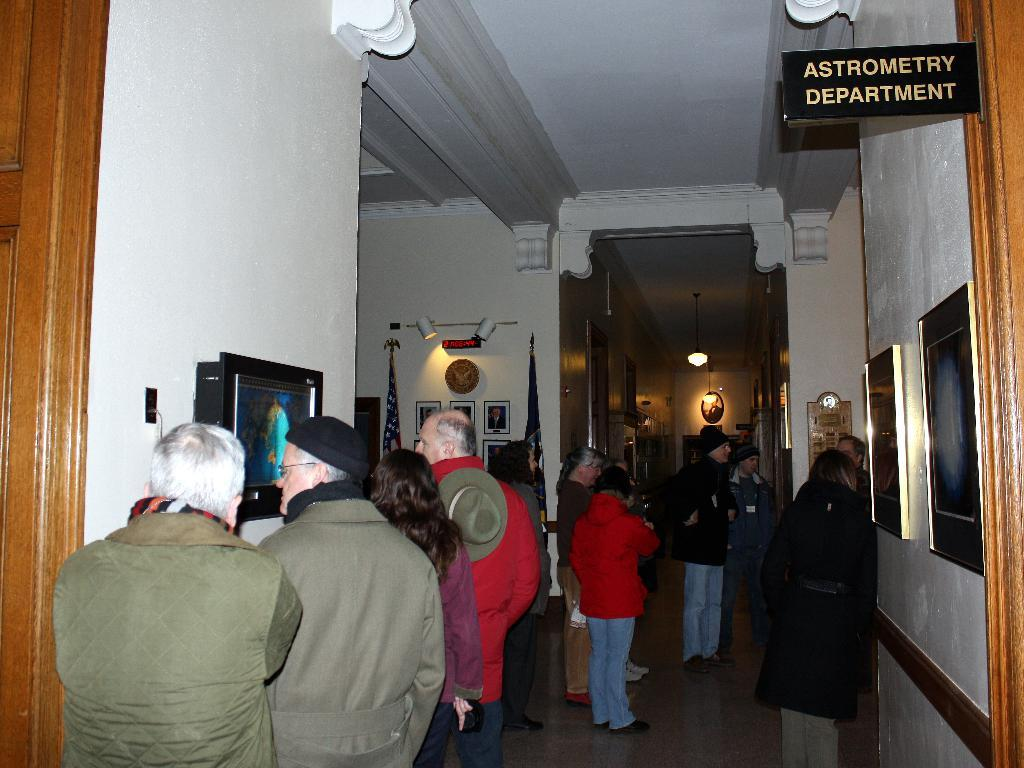What can be seen at the bottom of the image? There are people standing at the bottom of the image. What is located behind the people? There is a wall behind the people. What is attached to the wall? There are frames on the wall. What is visible at the top of the image? There is a roof visible at the top of the image. What can provide illumination in the image? There are lights present in the image. What type of reaction can be seen in the image? There is no reaction visible in the image; it only shows people standing, a wall with frames, a roof, and lights. Is there a birthday celebration happening in the image? There is no indication of a birthday celebration in the image. 